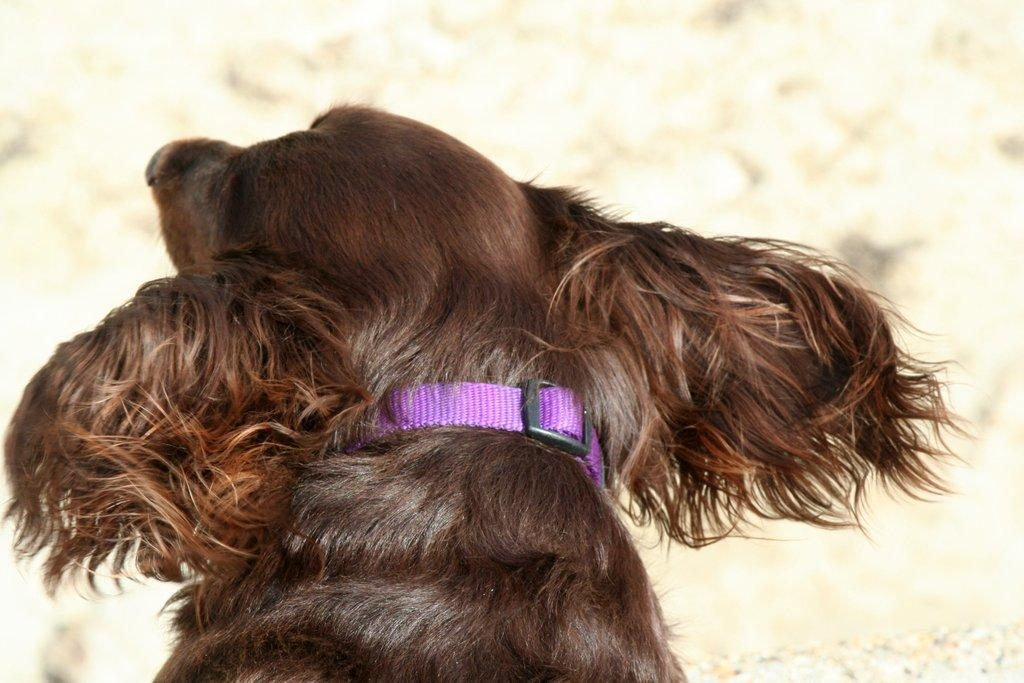What is the main subject in the foreground of the image? There is a dog in the foreground of the image. Can you describe the background of the image? The background of the image is blurry. How many babies are attempting to play with sticks in the background of the image? There are no babies or sticks present in the image, so this question cannot be answered. 